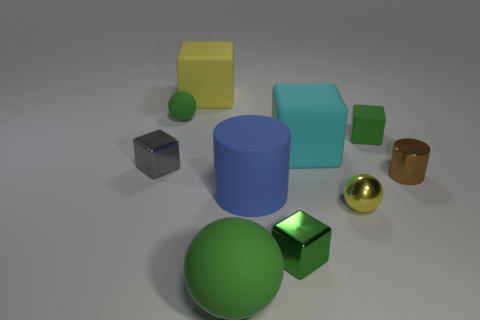Does the big ball have the same color as the small matte ball?
Offer a terse response. Yes. What number of small green spheres are right of the green metallic cube?
Provide a succinct answer. 0. There is a big cyan thing; does it have the same shape as the small green matte thing that is to the left of the blue object?
Offer a terse response. No. Are there any small metal objects of the same shape as the large blue rubber thing?
Offer a terse response. Yes. What is the shape of the green matte thing that is on the right side of the blue object on the left side of the cyan matte object?
Ensure brevity in your answer.  Cube. What is the shape of the large cyan rubber object that is right of the big yellow cube?
Your response must be concise. Cube. Do the matte ball behind the big green ball and the cube right of the cyan thing have the same color?
Offer a terse response. Yes. What number of tiny things are both to the right of the large cyan rubber cube and behind the tiny brown thing?
Offer a very short reply. 1. There is a blue object that is the same material as the large sphere; what is its size?
Offer a terse response. Large. The yellow rubber object is what size?
Keep it short and to the point. Large. 